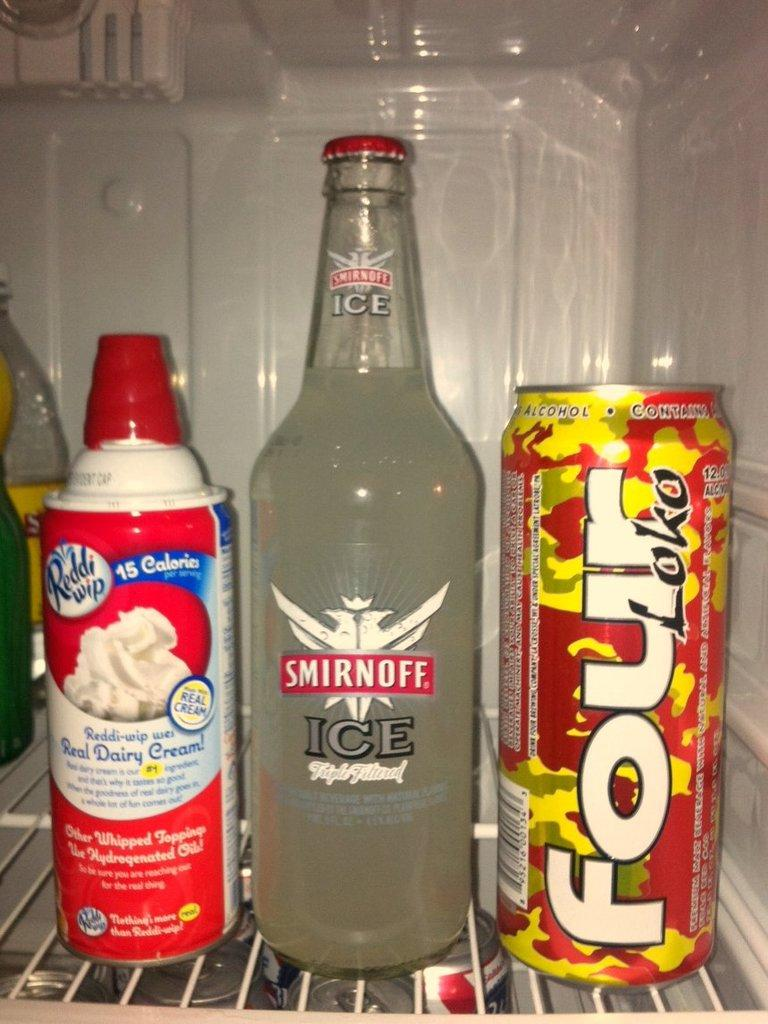How many bottles can be seen in the image? There are two bottles in the image. What other type of container is present in the image? There is a tin in the image. What type of record can be seen in the image? There is no record present in the image; only two bottles and a tin are mentioned in the facts. 